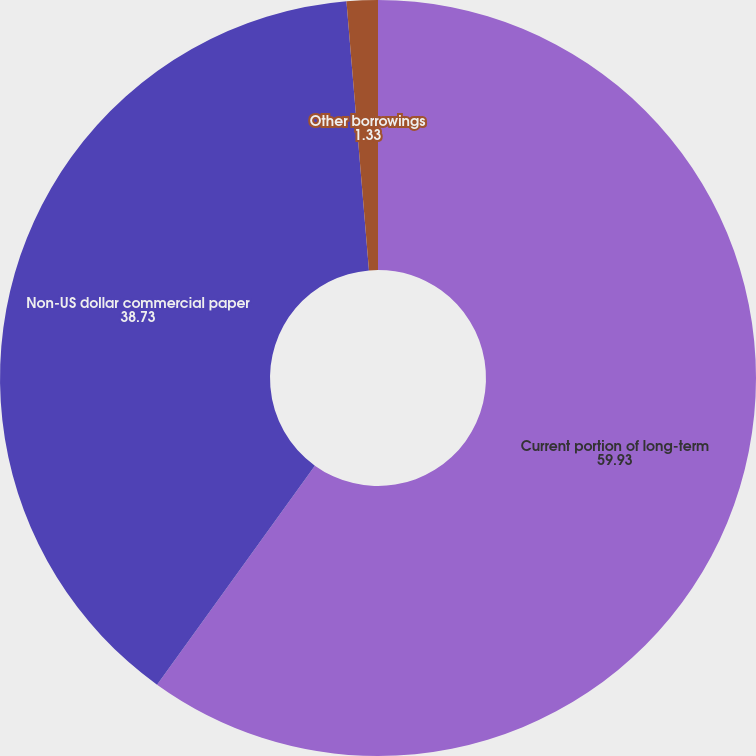<chart> <loc_0><loc_0><loc_500><loc_500><pie_chart><fcel>Current portion of long-term<fcel>Non-US dollar commercial paper<fcel>Other borrowings<nl><fcel>59.93%<fcel>38.73%<fcel>1.33%<nl></chart> 